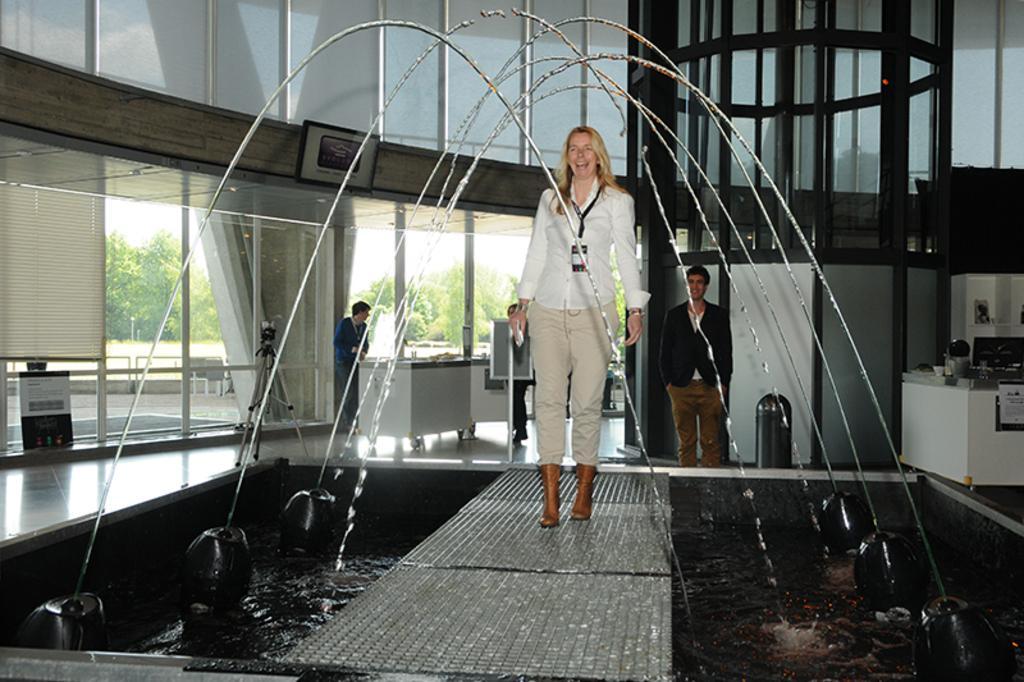Could you give a brief overview of what you see in this image? At the bottom of the image there is a ramp. On the ramp there is a lady walking. Near the ramp there are fountains. Behind the lady there are two persons standing. And also there are tables with few items on it. There is a bin and some other things. In the background there are glass walls and there is a poster with text on it. Behind the glass walls there are trees. 